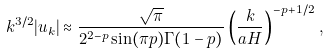Convert formula to latex. <formula><loc_0><loc_0><loc_500><loc_500>k ^ { 3 / 2 } | u _ { k } | \approx \frac { \sqrt { \pi } } { 2 ^ { 2 - p } \sin ( \pi p ) \Gamma ( 1 - p ) } \left ( \frac { k } { a H } \right ) ^ { - p + 1 / 2 } \, ,</formula> 